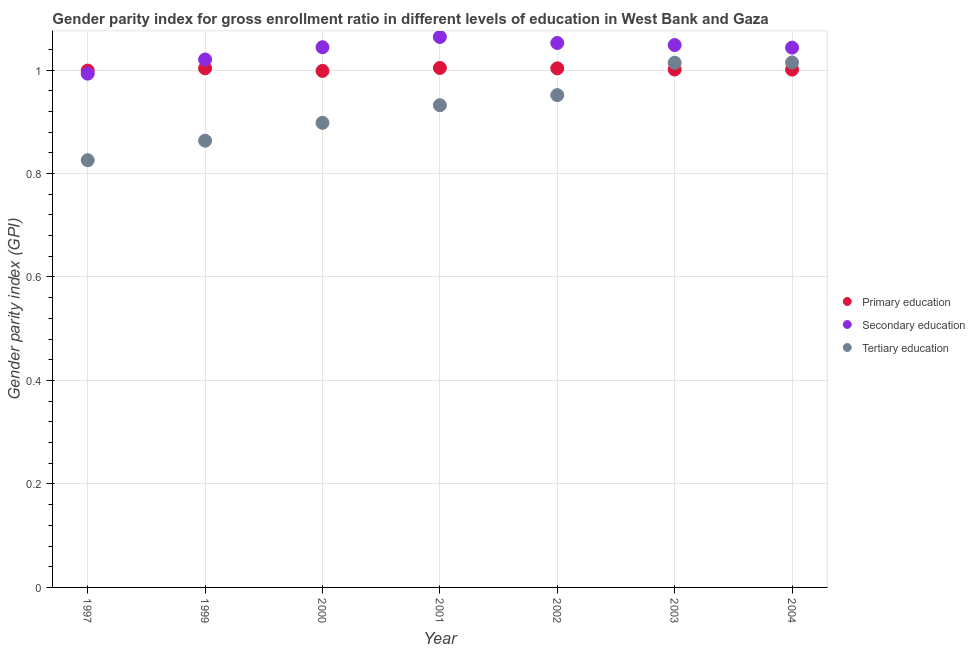What is the gender parity index in tertiary education in 2002?
Provide a short and direct response. 0.95. Across all years, what is the maximum gender parity index in secondary education?
Your response must be concise. 1.06. Across all years, what is the minimum gender parity index in primary education?
Offer a very short reply. 1. In which year was the gender parity index in secondary education maximum?
Offer a terse response. 2001. In which year was the gender parity index in primary education minimum?
Provide a succinct answer. 2000. What is the total gender parity index in tertiary education in the graph?
Your response must be concise. 6.5. What is the difference between the gender parity index in primary education in 1997 and that in 2004?
Your response must be concise. -0. What is the difference between the gender parity index in primary education in 2003 and the gender parity index in secondary education in 2001?
Your answer should be compact. -0.06. What is the average gender parity index in tertiary education per year?
Provide a short and direct response. 0.93. In the year 2002, what is the difference between the gender parity index in primary education and gender parity index in tertiary education?
Keep it short and to the point. 0.05. What is the ratio of the gender parity index in primary education in 1997 to that in 2002?
Offer a very short reply. 1. Is the gender parity index in tertiary education in 2003 less than that in 2004?
Make the answer very short. Yes. Is the difference between the gender parity index in tertiary education in 1999 and 2004 greater than the difference between the gender parity index in primary education in 1999 and 2004?
Your answer should be very brief. No. What is the difference between the highest and the second highest gender parity index in tertiary education?
Provide a succinct answer. 0. What is the difference between the highest and the lowest gender parity index in secondary education?
Offer a terse response. 0.07. In how many years, is the gender parity index in secondary education greater than the average gender parity index in secondary education taken over all years?
Ensure brevity in your answer.  5. How many dotlines are there?
Offer a very short reply. 3. How many years are there in the graph?
Keep it short and to the point. 7. What is the difference between two consecutive major ticks on the Y-axis?
Your answer should be compact. 0.2. How many legend labels are there?
Make the answer very short. 3. What is the title of the graph?
Offer a very short reply. Gender parity index for gross enrollment ratio in different levels of education in West Bank and Gaza. Does "Infant(male)" appear as one of the legend labels in the graph?
Make the answer very short. No. What is the label or title of the X-axis?
Provide a short and direct response. Year. What is the label or title of the Y-axis?
Make the answer very short. Gender parity index (GPI). What is the Gender parity index (GPI) of Primary education in 1997?
Give a very brief answer. 1. What is the Gender parity index (GPI) of Tertiary education in 1997?
Give a very brief answer. 0.83. What is the Gender parity index (GPI) of Primary education in 1999?
Give a very brief answer. 1. What is the Gender parity index (GPI) of Secondary education in 1999?
Ensure brevity in your answer.  1.02. What is the Gender parity index (GPI) in Tertiary education in 1999?
Offer a terse response. 0.86. What is the Gender parity index (GPI) of Primary education in 2000?
Offer a terse response. 1. What is the Gender parity index (GPI) of Secondary education in 2000?
Give a very brief answer. 1.04. What is the Gender parity index (GPI) of Tertiary education in 2000?
Provide a succinct answer. 0.9. What is the Gender parity index (GPI) in Primary education in 2001?
Your answer should be compact. 1. What is the Gender parity index (GPI) of Secondary education in 2001?
Provide a short and direct response. 1.06. What is the Gender parity index (GPI) in Tertiary education in 2001?
Your answer should be very brief. 0.93. What is the Gender parity index (GPI) of Primary education in 2002?
Offer a very short reply. 1. What is the Gender parity index (GPI) in Secondary education in 2002?
Make the answer very short. 1.05. What is the Gender parity index (GPI) of Tertiary education in 2002?
Provide a short and direct response. 0.95. What is the Gender parity index (GPI) of Primary education in 2003?
Your response must be concise. 1. What is the Gender parity index (GPI) in Secondary education in 2003?
Your answer should be compact. 1.05. What is the Gender parity index (GPI) in Tertiary education in 2003?
Offer a very short reply. 1.01. What is the Gender parity index (GPI) in Primary education in 2004?
Offer a very short reply. 1. What is the Gender parity index (GPI) of Secondary education in 2004?
Ensure brevity in your answer.  1.04. What is the Gender parity index (GPI) of Tertiary education in 2004?
Make the answer very short. 1.01. Across all years, what is the maximum Gender parity index (GPI) of Primary education?
Your response must be concise. 1. Across all years, what is the maximum Gender parity index (GPI) in Secondary education?
Keep it short and to the point. 1.06. Across all years, what is the maximum Gender parity index (GPI) in Tertiary education?
Your response must be concise. 1.01. Across all years, what is the minimum Gender parity index (GPI) of Primary education?
Offer a very short reply. 1. Across all years, what is the minimum Gender parity index (GPI) of Tertiary education?
Your response must be concise. 0.83. What is the total Gender parity index (GPI) of Primary education in the graph?
Your response must be concise. 7.01. What is the total Gender parity index (GPI) of Secondary education in the graph?
Your answer should be very brief. 7.26. What is the total Gender parity index (GPI) of Tertiary education in the graph?
Provide a succinct answer. 6.5. What is the difference between the Gender parity index (GPI) in Primary education in 1997 and that in 1999?
Provide a succinct answer. -0. What is the difference between the Gender parity index (GPI) of Secondary education in 1997 and that in 1999?
Offer a terse response. -0.03. What is the difference between the Gender parity index (GPI) in Tertiary education in 1997 and that in 1999?
Your answer should be compact. -0.04. What is the difference between the Gender parity index (GPI) in Primary education in 1997 and that in 2000?
Provide a succinct answer. 0. What is the difference between the Gender parity index (GPI) in Secondary education in 1997 and that in 2000?
Ensure brevity in your answer.  -0.05. What is the difference between the Gender parity index (GPI) of Tertiary education in 1997 and that in 2000?
Make the answer very short. -0.07. What is the difference between the Gender parity index (GPI) of Primary education in 1997 and that in 2001?
Your answer should be compact. -0.01. What is the difference between the Gender parity index (GPI) of Secondary education in 1997 and that in 2001?
Give a very brief answer. -0.07. What is the difference between the Gender parity index (GPI) of Tertiary education in 1997 and that in 2001?
Keep it short and to the point. -0.11. What is the difference between the Gender parity index (GPI) in Primary education in 1997 and that in 2002?
Provide a succinct answer. -0. What is the difference between the Gender parity index (GPI) in Secondary education in 1997 and that in 2002?
Give a very brief answer. -0.06. What is the difference between the Gender parity index (GPI) in Tertiary education in 1997 and that in 2002?
Keep it short and to the point. -0.13. What is the difference between the Gender parity index (GPI) of Primary education in 1997 and that in 2003?
Provide a succinct answer. -0. What is the difference between the Gender parity index (GPI) of Secondary education in 1997 and that in 2003?
Give a very brief answer. -0.06. What is the difference between the Gender parity index (GPI) in Tertiary education in 1997 and that in 2003?
Offer a terse response. -0.19. What is the difference between the Gender parity index (GPI) of Primary education in 1997 and that in 2004?
Provide a succinct answer. -0. What is the difference between the Gender parity index (GPI) of Secondary education in 1997 and that in 2004?
Keep it short and to the point. -0.05. What is the difference between the Gender parity index (GPI) of Tertiary education in 1997 and that in 2004?
Your answer should be compact. -0.19. What is the difference between the Gender parity index (GPI) of Primary education in 1999 and that in 2000?
Keep it short and to the point. 0.01. What is the difference between the Gender parity index (GPI) in Secondary education in 1999 and that in 2000?
Provide a succinct answer. -0.02. What is the difference between the Gender parity index (GPI) in Tertiary education in 1999 and that in 2000?
Your answer should be compact. -0.03. What is the difference between the Gender parity index (GPI) in Primary education in 1999 and that in 2001?
Provide a short and direct response. -0. What is the difference between the Gender parity index (GPI) in Secondary education in 1999 and that in 2001?
Your response must be concise. -0.04. What is the difference between the Gender parity index (GPI) in Tertiary education in 1999 and that in 2001?
Ensure brevity in your answer.  -0.07. What is the difference between the Gender parity index (GPI) in Secondary education in 1999 and that in 2002?
Keep it short and to the point. -0.03. What is the difference between the Gender parity index (GPI) of Tertiary education in 1999 and that in 2002?
Give a very brief answer. -0.09. What is the difference between the Gender parity index (GPI) of Primary education in 1999 and that in 2003?
Offer a very short reply. 0. What is the difference between the Gender parity index (GPI) of Secondary education in 1999 and that in 2003?
Make the answer very short. -0.03. What is the difference between the Gender parity index (GPI) of Tertiary education in 1999 and that in 2003?
Offer a terse response. -0.15. What is the difference between the Gender parity index (GPI) of Primary education in 1999 and that in 2004?
Your response must be concise. 0. What is the difference between the Gender parity index (GPI) in Secondary education in 1999 and that in 2004?
Offer a terse response. -0.02. What is the difference between the Gender parity index (GPI) of Tertiary education in 1999 and that in 2004?
Offer a terse response. -0.15. What is the difference between the Gender parity index (GPI) of Primary education in 2000 and that in 2001?
Make the answer very short. -0.01. What is the difference between the Gender parity index (GPI) of Secondary education in 2000 and that in 2001?
Provide a succinct answer. -0.02. What is the difference between the Gender parity index (GPI) of Tertiary education in 2000 and that in 2001?
Provide a short and direct response. -0.03. What is the difference between the Gender parity index (GPI) in Primary education in 2000 and that in 2002?
Your answer should be compact. -0. What is the difference between the Gender parity index (GPI) in Secondary education in 2000 and that in 2002?
Keep it short and to the point. -0.01. What is the difference between the Gender parity index (GPI) in Tertiary education in 2000 and that in 2002?
Offer a very short reply. -0.05. What is the difference between the Gender parity index (GPI) of Primary education in 2000 and that in 2003?
Provide a short and direct response. -0. What is the difference between the Gender parity index (GPI) in Secondary education in 2000 and that in 2003?
Make the answer very short. -0. What is the difference between the Gender parity index (GPI) of Tertiary education in 2000 and that in 2003?
Provide a short and direct response. -0.12. What is the difference between the Gender parity index (GPI) of Primary education in 2000 and that in 2004?
Your response must be concise. -0. What is the difference between the Gender parity index (GPI) of Secondary education in 2000 and that in 2004?
Your answer should be very brief. 0. What is the difference between the Gender parity index (GPI) of Tertiary education in 2000 and that in 2004?
Provide a succinct answer. -0.12. What is the difference between the Gender parity index (GPI) of Primary education in 2001 and that in 2002?
Your answer should be very brief. 0. What is the difference between the Gender parity index (GPI) of Secondary education in 2001 and that in 2002?
Keep it short and to the point. 0.01. What is the difference between the Gender parity index (GPI) of Tertiary education in 2001 and that in 2002?
Provide a short and direct response. -0.02. What is the difference between the Gender parity index (GPI) of Primary education in 2001 and that in 2003?
Give a very brief answer. 0. What is the difference between the Gender parity index (GPI) of Secondary education in 2001 and that in 2003?
Your answer should be compact. 0.02. What is the difference between the Gender parity index (GPI) in Tertiary education in 2001 and that in 2003?
Give a very brief answer. -0.08. What is the difference between the Gender parity index (GPI) in Primary education in 2001 and that in 2004?
Keep it short and to the point. 0. What is the difference between the Gender parity index (GPI) of Secondary education in 2001 and that in 2004?
Give a very brief answer. 0.02. What is the difference between the Gender parity index (GPI) in Tertiary education in 2001 and that in 2004?
Your answer should be very brief. -0.08. What is the difference between the Gender parity index (GPI) of Primary education in 2002 and that in 2003?
Provide a succinct answer. 0. What is the difference between the Gender parity index (GPI) of Secondary education in 2002 and that in 2003?
Offer a terse response. 0. What is the difference between the Gender parity index (GPI) of Tertiary education in 2002 and that in 2003?
Make the answer very short. -0.06. What is the difference between the Gender parity index (GPI) of Primary education in 2002 and that in 2004?
Ensure brevity in your answer.  0. What is the difference between the Gender parity index (GPI) of Secondary education in 2002 and that in 2004?
Offer a very short reply. 0.01. What is the difference between the Gender parity index (GPI) in Tertiary education in 2002 and that in 2004?
Provide a short and direct response. -0.06. What is the difference between the Gender parity index (GPI) in Secondary education in 2003 and that in 2004?
Make the answer very short. 0.01. What is the difference between the Gender parity index (GPI) in Tertiary education in 2003 and that in 2004?
Keep it short and to the point. -0. What is the difference between the Gender parity index (GPI) of Primary education in 1997 and the Gender parity index (GPI) of Secondary education in 1999?
Make the answer very short. -0.02. What is the difference between the Gender parity index (GPI) in Primary education in 1997 and the Gender parity index (GPI) in Tertiary education in 1999?
Ensure brevity in your answer.  0.14. What is the difference between the Gender parity index (GPI) in Secondary education in 1997 and the Gender parity index (GPI) in Tertiary education in 1999?
Provide a succinct answer. 0.13. What is the difference between the Gender parity index (GPI) in Primary education in 1997 and the Gender parity index (GPI) in Secondary education in 2000?
Your answer should be compact. -0.05. What is the difference between the Gender parity index (GPI) in Primary education in 1997 and the Gender parity index (GPI) in Tertiary education in 2000?
Provide a succinct answer. 0.1. What is the difference between the Gender parity index (GPI) in Secondary education in 1997 and the Gender parity index (GPI) in Tertiary education in 2000?
Offer a very short reply. 0.1. What is the difference between the Gender parity index (GPI) in Primary education in 1997 and the Gender parity index (GPI) in Secondary education in 2001?
Your response must be concise. -0.07. What is the difference between the Gender parity index (GPI) in Primary education in 1997 and the Gender parity index (GPI) in Tertiary education in 2001?
Make the answer very short. 0.07. What is the difference between the Gender parity index (GPI) of Secondary education in 1997 and the Gender parity index (GPI) of Tertiary education in 2001?
Provide a succinct answer. 0.06. What is the difference between the Gender parity index (GPI) of Primary education in 1997 and the Gender parity index (GPI) of Secondary education in 2002?
Give a very brief answer. -0.05. What is the difference between the Gender parity index (GPI) in Primary education in 1997 and the Gender parity index (GPI) in Tertiary education in 2002?
Offer a very short reply. 0.05. What is the difference between the Gender parity index (GPI) in Secondary education in 1997 and the Gender parity index (GPI) in Tertiary education in 2002?
Your response must be concise. 0.04. What is the difference between the Gender parity index (GPI) of Primary education in 1997 and the Gender parity index (GPI) of Secondary education in 2003?
Keep it short and to the point. -0.05. What is the difference between the Gender parity index (GPI) of Primary education in 1997 and the Gender parity index (GPI) of Tertiary education in 2003?
Your answer should be very brief. -0.02. What is the difference between the Gender parity index (GPI) in Secondary education in 1997 and the Gender parity index (GPI) in Tertiary education in 2003?
Provide a succinct answer. -0.02. What is the difference between the Gender parity index (GPI) of Primary education in 1997 and the Gender parity index (GPI) of Secondary education in 2004?
Give a very brief answer. -0.04. What is the difference between the Gender parity index (GPI) in Primary education in 1997 and the Gender parity index (GPI) in Tertiary education in 2004?
Offer a terse response. -0.02. What is the difference between the Gender parity index (GPI) in Secondary education in 1997 and the Gender parity index (GPI) in Tertiary education in 2004?
Provide a short and direct response. -0.02. What is the difference between the Gender parity index (GPI) in Primary education in 1999 and the Gender parity index (GPI) in Secondary education in 2000?
Provide a succinct answer. -0.04. What is the difference between the Gender parity index (GPI) in Primary education in 1999 and the Gender parity index (GPI) in Tertiary education in 2000?
Give a very brief answer. 0.11. What is the difference between the Gender parity index (GPI) of Secondary education in 1999 and the Gender parity index (GPI) of Tertiary education in 2000?
Ensure brevity in your answer.  0.12. What is the difference between the Gender parity index (GPI) in Primary education in 1999 and the Gender parity index (GPI) in Secondary education in 2001?
Offer a very short reply. -0.06. What is the difference between the Gender parity index (GPI) of Primary education in 1999 and the Gender parity index (GPI) of Tertiary education in 2001?
Ensure brevity in your answer.  0.07. What is the difference between the Gender parity index (GPI) in Secondary education in 1999 and the Gender parity index (GPI) in Tertiary education in 2001?
Your answer should be compact. 0.09. What is the difference between the Gender parity index (GPI) of Primary education in 1999 and the Gender parity index (GPI) of Secondary education in 2002?
Give a very brief answer. -0.05. What is the difference between the Gender parity index (GPI) in Primary education in 1999 and the Gender parity index (GPI) in Tertiary education in 2002?
Offer a terse response. 0.05. What is the difference between the Gender parity index (GPI) of Secondary education in 1999 and the Gender parity index (GPI) of Tertiary education in 2002?
Provide a short and direct response. 0.07. What is the difference between the Gender parity index (GPI) in Primary education in 1999 and the Gender parity index (GPI) in Secondary education in 2003?
Give a very brief answer. -0.04. What is the difference between the Gender parity index (GPI) of Primary education in 1999 and the Gender parity index (GPI) of Tertiary education in 2003?
Make the answer very short. -0.01. What is the difference between the Gender parity index (GPI) of Secondary education in 1999 and the Gender parity index (GPI) of Tertiary education in 2003?
Make the answer very short. 0.01. What is the difference between the Gender parity index (GPI) in Primary education in 1999 and the Gender parity index (GPI) in Secondary education in 2004?
Your answer should be very brief. -0.04. What is the difference between the Gender parity index (GPI) in Primary education in 1999 and the Gender parity index (GPI) in Tertiary education in 2004?
Make the answer very short. -0.01. What is the difference between the Gender parity index (GPI) of Secondary education in 1999 and the Gender parity index (GPI) of Tertiary education in 2004?
Keep it short and to the point. 0.01. What is the difference between the Gender parity index (GPI) of Primary education in 2000 and the Gender parity index (GPI) of Secondary education in 2001?
Ensure brevity in your answer.  -0.07. What is the difference between the Gender parity index (GPI) in Primary education in 2000 and the Gender parity index (GPI) in Tertiary education in 2001?
Keep it short and to the point. 0.07. What is the difference between the Gender parity index (GPI) in Secondary education in 2000 and the Gender parity index (GPI) in Tertiary education in 2001?
Provide a short and direct response. 0.11. What is the difference between the Gender parity index (GPI) of Primary education in 2000 and the Gender parity index (GPI) of Secondary education in 2002?
Offer a very short reply. -0.05. What is the difference between the Gender parity index (GPI) of Primary education in 2000 and the Gender parity index (GPI) of Tertiary education in 2002?
Give a very brief answer. 0.05. What is the difference between the Gender parity index (GPI) in Secondary education in 2000 and the Gender parity index (GPI) in Tertiary education in 2002?
Your answer should be very brief. 0.09. What is the difference between the Gender parity index (GPI) in Primary education in 2000 and the Gender parity index (GPI) in Secondary education in 2003?
Your answer should be very brief. -0.05. What is the difference between the Gender parity index (GPI) of Primary education in 2000 and the Gender parity index (GPI) of Tertiary education in 2003?
Provide a short and direct response. -0.02. What is the difference between the Gender parity index (GPI) of Secondary education in 2000 and the Gender parity index (GPI) of Tertiary education in 2003?
Offer a very short reply. 0.03. What is the difference between the Gender parity index (GPI) of Primary education in 2000 and the Gender parity index (GPI) of Secondary education in 2004?
Your answer should be compact. -0.04. What is the difference between the Gender parity index (GPI) in Primary education in 2000 and the Gender parity index (GPI) in Tertiary education in 2004?
Offer a terse response. -0.02. What is the difference between the Gender parity index (GPI) of Secondary education in 2000 and the Gender parity index (GPI) of Tertiary education in 2004?
Your answer should be very brief. 0.03. What is the difference between the Gender parity index (GPI) in Primary education in 2001 and the Gender parity index (GPI) in Secondary education in 2002?
Keep it short and to the point. -0.05. What is the difference between the Gender parity index (GPI) in Primary education in 2001 and the Gender parity index (GPI) in Tertiary education in 2002?
Your answer should be very brief. 0.05. What is the difference between the Gender parity index (GPI) of Secondary education in 2001 and the Gender parity index (GPI) of Tertiary education in 2002?
Keep it short and to the point. 0.11. What is the difference between the Gender parity index (GPI) in Primary education in 2001 and the Gender parity index (GPI) in Secondary education in 2003?
Ensure brevity in your answer.  -0.04. What is the difference between the Gender parity index (GPI) of Primary education in 2001 and the Gender parity index (GPI) of Tertiary education in 2003?
Provide a succinct answer. -0.01. What is the difference between the Gender parity index (GPI) of Secondary education in 2001 and the Gender parity index (GPI) of Tertiary education in 2003?
Your answer should be compact. 0.05. What is the difference between the Gender parity index (GPI) of Primary education in 2001 and the Gender parity index (GPI) of Secondary education in 2004?
Give a very brief answer. -0.04. What is the difference between the Gender parity index (GPI) in Primary education in 2001 and the Gender parity index (GPI) in Tertiary education in 2004?
Offer a very short reply. -0.01. What is the difference between the Gender parity index (GPI) of Secondary education in 2001 and the Gender parity index (GPI) of Tertiary education in 2004?
Your response must be concise. 0.05. What is the difference between the Gender parity index (GPI) of Primary education in 2002 and the Gender parity index (GPI) of Secondary education in 2003?
Your response must be concise. -0.05. What is the difference between the Gender parity index (GPI) of Primary education in 2002 and the Gender parity index (GPI) of Tertiary education in 2003?
Give a very brief answer. -0.01. What is the difference between the Gender parity index (GPI) of Secondary education in 2002 and the Gender parity index (GPI) of Tertiary education in 2003?
Give a very brief answer. 0.04. What is the difference between the Gender parity index (GPI) in Primary education in 2002 and the Gender parity index (GPI) in Secondary education in 2004?
Your answer should be compact. -0.04. What is the difference between the Gender parity index (GPI) in Primary education in 2002 and the Gender parity index (GPI) in Tertiary education in 2004?
Make the answer very short. -0.01. What is the difference between the Gender parity index (GPI) of Secondary education in 2002 and the Gender parity index (GPI) of Tertiary education in 2004?
Ensure brevity in your answer.  0.04. What is the difference between the Gender parity index (GPI) of Primary education in 2003 and the Gender parity index (GPI) of Secondary education in 2004?
Provide a short and direct response. -0.04. What is the difference between the Gender parity index (GPI) in Primary education in 2003 and the Gender parity index (GPI) in Tertiary education in 2004?
Offer a terse response. -0.01. What is the difference between the Gender parity index (GPI) in Secondary education in 2003 and the Gender parity index (GPI) in Tertiary education in 2004?
Offer a terse response. 0.03. What is the average Gender parity index (GPI) of Primary education per year?
Provide a succinct answer. 1. What is the average Gender parity index (GPI) of Secondary education per year?
Offer a very short reply. 1.04. What is the average Gender parity index (GPI) of Tertiary education per year?
Your answer should be very brief. 0.93. In the year 1997, what is the difference between the Gender parity index (GPI) in Primary education and Gender parity index (GPI) in Secondary education?
Ensure brevity in your answer.  0.01. In the year 1997, what is the difference between the Gender parity index (GPI) in Primary education and Gender parity index (GPI) in Tertiary education?
Give a very brief answer. 0.17. In the year 1997, what is the difference between the Gender parity index (GPI) in Secondary education and Gender parity index (GPI) in Tertiary education?
Keep it short and to the point. 0.17. In the year 1999, what is the difference between the Gender parity index (GPI) in Primary education and Gender parity index (GPI) in Secondary education?
Offer a very short reply. -0.02. In the year 1999, what is the difference between the Gender parity index (GPI) of Primary education and Gender parity index (GPI) of Tertiary education?
Give a very brief answer. 0.14. In the year 1999, what is the difference between the Gender parity index (GPI) in Secondary education and Gender parity index (GPI) in Tertiary education?
Provide a short and direct response. 0.16. In the year 2000, what is the difference between the Gender parity index (GPI) of Primary education and Gender parity index (GPI) of Secondary education?
Provide a short and direct response. -0.05. In the year 2000, what is the difference between the Gender parity index (GPI) of Primary education and Gender parity index (GPI) of Tertiary education?
Provide a succinct answer. 0.1. In the year 2000, what is the difference between the Gender parity index (GPI) in Secondary education and Gender parity index (GPI) in Tertiary education?
Give a very brief answer. 0.15. In the year 2001, what is the difference between the Gender parity index (GPI) of Primary education and Gender parity index (GPI) of Secondary education?
Your response must be concise. -0.06. In the year 2001, what is the difference between the Gender parity index (GPI) in Primary education and Gender parity index (GPI) in Tertiary education?
Keep it short and to the point. 0.07. In the year 2001, what is the difference between the Gender parity index (GPI) in Secondary education and Gender parity index (GPI) in Tertiary education?
Your answer should be very brief. 0.13. In the year 2002, what is the difference between the Gender parity index (GPI) of Primary education and Gender parity index (GPI) of Secondary education?
Provide a short and direct response. -0.05. In the year 2002, what is the difference between the Gender parity index (GPI) of Primary education and Gender parity index (GPI) of Tertiary education?
Keep it short and to the point. 0.05. In the year 2002, what is the difference between the Gender parity index (GPI) in Secondary education and Gender parity index (GPI) in Tertiary education?
Keep it short and to the point. 0.1. In the year 2003, what is the difference between the Gender parity index (GPI) in Primary education and Gender parity index (GPI) in Secondary education?
Offer a very short reply. -0.05. In the year 2003, what is the difference between the Gender parity index (GPI) of Primary education and Gender parity index (GPI) of Tertiary education?
Your response must be concise. -0.01. In the year 2003, what is the difference between the Gender parity index (GPI) of Secondary education and Gender parity index (GPI) of Tertiary education?
Make the answer very short. 0.03. In the year 2004, what is the difference between the Gender parity index (GPI) of Primary education and Gender parity index (GPI) of Secondary education?
Keep it short and to the point. -0.04. In the year 2004, what is the difference between the Gender parity index (GPI) in Primary education and Gender parity index (GPI) in Tertiary education?
Your response must be concise. -0.01. In the year 2004, what is the difference between the Gender parity index (GPI) of Secondary education and Gender parity index (GPI) of Tertiary education?
Provide a short and direct response. 0.03. What is the ratio of the Gender parity index (GPI) of Primary education in 1997 to that in 1999?
Your answer should be very brief. 1. What is the ratio of the Gender parity index (GPI) in Secondary education in 1997 to that in 1999?
Keep it short and to the point. 0.97. What is the ratio of the Gender parity index (GPI) of Tertiary education in 1997 to that in 1999?
Your response must be concise. 0.96. What is the ratio of the Gender parity index (GPI) of Secondary education in 1997 to that in 2000?
Ensure brevity in your answer.  0.95. What is the ratio of the Gender parity index (GPI) in Tertiary education in 1997 to that in 2000?
Your answer should be compact. 0.92. What is the ratio of the Gender parity index (GPI) in Secondary education in 1997 to that in 2001?
Offer a terse response. 0.93. What is the ratio of the Gender parity index (GPI) of Tertiary education in 1997 to that in 2001?
Your response must be concise. 0.89. What is the ratio of the Gender parity index (GPI) in Secondary education in 1997 to that in 2002?
Ensure brevity in your answer.  0.94. What is the ratio of the Gender parity index (GPI) in Tertiary education in 1997 to that in 2002?
Ensure brevity in your answer.  0.87. What is the ratio of the Gender parity index (GPI) of Secondary education in 1997 to that in 2003?
Your response must be concise. 0.95. What is the ratio of the Gender parity index (GPI) in Tertiary education in 1997 to that in 2003?
Your response must be concise. 0.81. What is the ratio of the Gender parity index (GPI) of Secondary education in 1997 to that in 2004?
Ensure brevity in your answer.  0.95. What is the ratio of the Gender parity index (GPI) of Tertiary education in 1997 to that in 2004?
Your answer should be very brief. 0.81. What is the ratio of the Gender parity index (GPI) of Primary education in 1999 to that in 2000?
Offer a terse response. 1. What is the ratio of the Gender parity index (GPI) of Secondary education in 1999 to that in 2000?
Your answer should be very brief. 0.98. What is the ratio of the Gender parity index (GPI) of Tertiary education in 1999 to that in 2000?
Your answer should be very brief. 0.96. What is the ratio of the Gender parity index (GPI) of Primary education in 1999 to that in 2001?
Keep it short and to the point. 1. What is the ratio of the Gender parity index (GPI) in Secondary education in 1999 to that in 2001?
Your answer should be compact. 0.96. What is the ratio of the Gender parity index (GPI) in Tertiary education in 1999 to that in 2001?
Offer a terse response. 0.93. What is the ratio of the Gender parity index (GPI) in Primary education in 1999 to that in 2002?
Give a very brief answer. 1. What is the ratio of the Gender parity index (GPI) in Secondary education in 1999 to that in 2002?
Your answer should be very brief. 0.97. What is the ratio of the Gender parity index (GPI) of Tertiary education in 1999 to that in 2002?
Ensure brevity in your answer.  0.91. What is the ratio of the Gender parity index (GPI) in Secondary education in 1999 to that in 2003?
Make the answer very short. 0.97. What is the ratio of the Gender parity index (GPI) in Tertiary education in 1999 to that in 2003?
Make the answer very short. 0.85. What is the ratio of the Gender parity index (GPI) in Secondary education in 1999 to that in 2004?
Offer a very short reply. 0.98. What is the ratio of the Gender parity index (GPI) of Tertiary education in 1999 to that in 2004?
Your answer should be very brief. 0.85. What is the ratio of the Gender parity index (GPI) in Secondary education in 2000 to that in 2001?
Ensure brevity in your answer.  0.98. What is the ratio of the Gender parity index (GPI) of Tertiary education in 2000 to that in 2001?
Your answer should be very brief. 0.96. What is the ratio of the Gender parity index (GPI) of Primary education in 2000 to that in 2002?
Your answer should be very brief. 1. What is the ratio of the Gender parity index (GPI) in Secondary education in 2000 to that in 2002?
Provide a succinct answer. 0.99. What is the ratio of the Gender parity index (GPI) of Tertiary education in 2000 to that in 2002?
Provide a succinct answer. 0.94. What is the ratio of the Gender parity index (GPI) in Primary education in 2000 to that in 2003?
Give a very brief answer. 1. What is the ratio of the Gender parity index (GPI) of Tertiary education in 2000 to that in 2003?
Your answer should be compact. 0.89. What is the ratio of the Gender parity index (GPI) of Tertiary education in 2000 to that in 2004?
Give a very brief answer. 0.89. What is the ratio of the Gender parity index (GPI) in Primary education in 2001 to that in 2002?
Your response must be concise. 1. What is the ratio of the Gender parity index (GPI) of Secondary education in 2001 to that in 2002?
Make the answer very short. 1.01. What is the ratio of the Gender parity index (GPI) in Tertiary education in 2001 to that in 2002?
Give a very brief answer. 0.98. What is the ratio of the Gender parity index (GPI) of Secondary education in 2001 to that in 2003?
Offer a very short reply. 1.01. What is the ratio of the Gender parity index (GPI) of Tertiary education in 2001 to that in 2003?
Offer a terse response. 0.92. What is the ratio of the Gender parity index (GPI) in Primary education in 2001 to that in 2004?
Make the answer very short. 1. What is the ratio of the Gender parity index (GPI) in Secondary education in 2001 to that in 2004?
Provide a short and direct response. 1.02. What is the ratio of the Gender parity index (GPI) in Tertiary education in 2001 to that in 2004?
Make the answer very short. 0.92. What is the ratio of the Gender parity index (GPI) of Primary education in 2002 to that in 2003?
Give a very brief answer. 1. What is the ratio of the Gender parity index (GPI) in Secondary education in 2002 to that in 2003?
Make the answer very short. 1. What is the ratio of the Gender parity index (GPI) in Tertiary education in 2002 to that in 2003?
Give a very brief answer. 0.94. What is the ratio of the Gender parity index (GPI) of Primary education in 2002 to that in 2004?
Your answer should be very brief. 1. What is the ratio of the Gender parity index (GPI) of Secondary education in 2002 to that in 2004?
Your response must be concise. 1.01. What is the ratio of the Gender parity index (GPI) in Tertiary education in 2002 to that in 2004?
Provide a short and direct response. 0.94. What is the ratio of the Gender parity index (GPI) of Primary education in 2003 to that in 2004?
Make the answer very short. 1. What is the difference between the highest and the second highest Gender parity index (GPI) of Primary education?
Make the answer very short. 0. What is the difference between the highest and the second highest Gender parity index (GPI) of Secondary education?
Your answer should be compact. 0.01. What is the difference between the highest and the second highest Gender parity index (GPI) of Tertiary education?
Offer a very short reply. 0. What is the difference between the highest and the lowest Gender parity index (GPI) of Primary education?
Provide a succinct answer. 0.01. What is the difference between the highest and the lowest Gender parity index (GPI) of Secondary education?
Make the answer very short. 0.07. What is the difference between the highest and the lowest Gender parity index (GPI) in Tertiary education?
Make the answer very short. 0.19. 